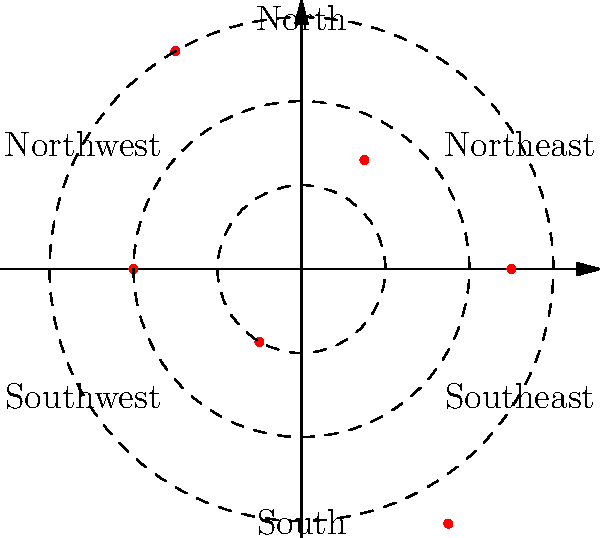The polar coordinate plot above shows poverty rates across different regions. Which region has the highest poverty rate, and what is the approximate value? To answer this question, we need to analyze the polar coordinate plot:

1. The plot shows six regions: North, Northeast, Southeast, South, Southwest, and Northwest.
2. The distance from the center represents the poverty rate for each region.
3. The concentric dashed circles represent poverty rate levels of 10%, 20%, and 30%.

Looking at each region:
- North: approximately 25%
- Northeast: approximately 15%
- Southeast: approximately 30%
- South: approximately 20%
- Southwest: approximately 10%
- Northwest: extends beyond the 30% circle, approximately 35%

The region with the highest poverty rate is the Northwest, with a rate of approximately 35%.
Answer: Northwest, 35% 